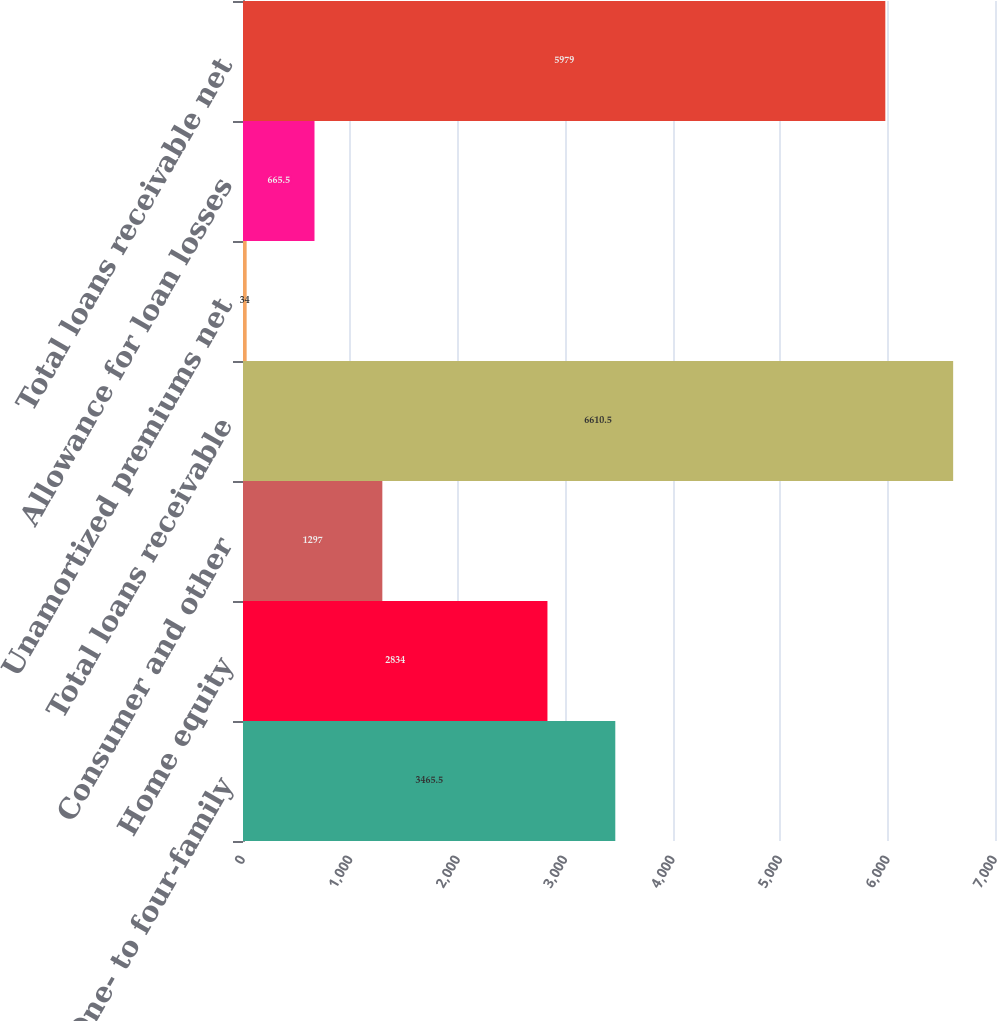<chart> <loc_0><loc_0><loc_500><loc_500><bar_chart><fcel>One- to four-family<fcel>Home equity<fcel>Consumer and other<fcel>Total loans receivable<fcel>Unamortized premiums net<fcel>Allowance for loan losses<fcel>Total loans receivable net<nl><fcel>3465.5<fcel>2834<fcel>1297<fcel>6610.5<fcel>34<fcel>665.5<fcel>5979<nl></chart> 